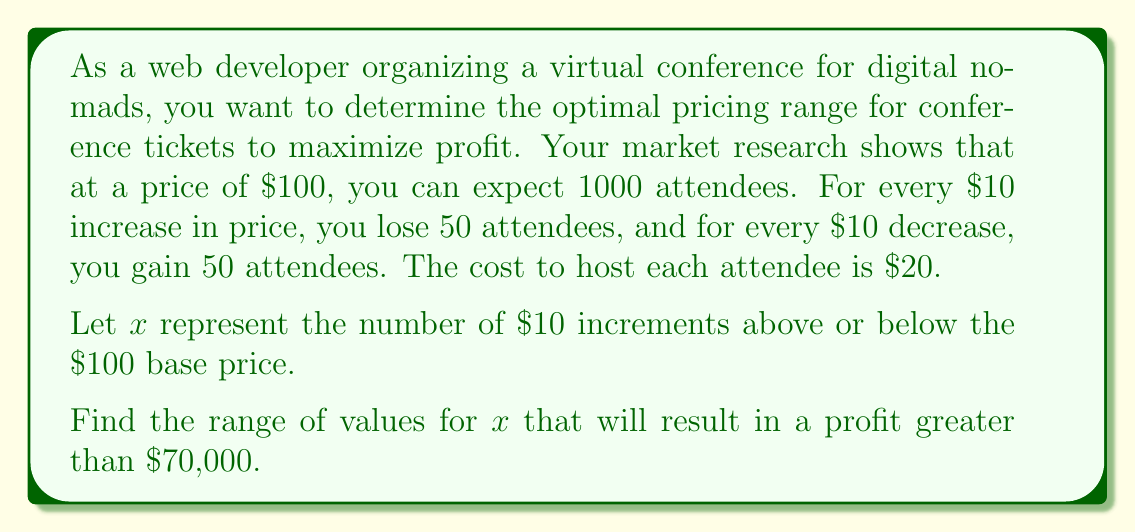Can you answer this question? Let's approach this step-by-step:

1) First, let's define our variables:
   - $P$ = price per ticket
   - $A$ = number of attendees
   - $R$ = revenue
   - $C$ = total cost
   - $\Pi$ = profit

2) We can express price and attendees in terms of $x$:
   $P = 100 + 10x$
   $A = 1000 - 50x$

3) Revenue is price times number of attendees:
   $R = P \cdot A = (100 + 10x)(1000 - 50x) = 100000 + 10000x - 5000x - 500x^2 = 100000 + 5000x - 500x^2$

4) Cost is $20 per attendee:
   $C = 20A = 20(1000 - 50x) = 20000 - 1000x$

5) Profit is revenue minus cost:
   $\Pi = R - C = (100000 + 5000x - 500x^2) - (20000 - 1000x)$
   $\Pi = 80000 + 6000x - 500x^2$

6) We want profit to be greater than $70,000:
   $80000 + 6000x - 500x^2 > 70000$
   $6000x - 500x^2 > -10000$
   $500x^2 - 6000x + 10000 < 0$

7) This is a quadratic inequality. We can solve it by finding the roots of the quadratic equation:
   $500x^2 - 6000x + 10000 = 0$
   
   Using the quadratic formula: $x = \frac{-b \pm \sqrt{b^2 - 4ac}}{2a}$
   
   $x = \frac{6000 \pm \sqrt{36000000 - 20000000}}{1000} = \frac{6000 \pm \sqrt{16000000}}{1000} = \frac{6000 \pm 4000}{1000}$

   $x = 10$ or $x = 2$

8) The inequality is satisfied between these two roots. Therefore, $2 < x < 10$.

9) Translating this back to price:
   $100 + 10(2) < P < 100 + 10(10)$
   $120 < P < 200$
Answer: The optimal pricing range for conference tickets to maximize profit (ensuring profit is greater than $70,000) is between $120 and $200. 